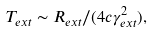Convert formula to latex. <formula><loc_0><loc_0><loc_500><loc_500>T _ { e x t } \sim R _ { e x t } / ( 4 c \gamma _ { e x t } ^ { 2 } ) ,</formula> 